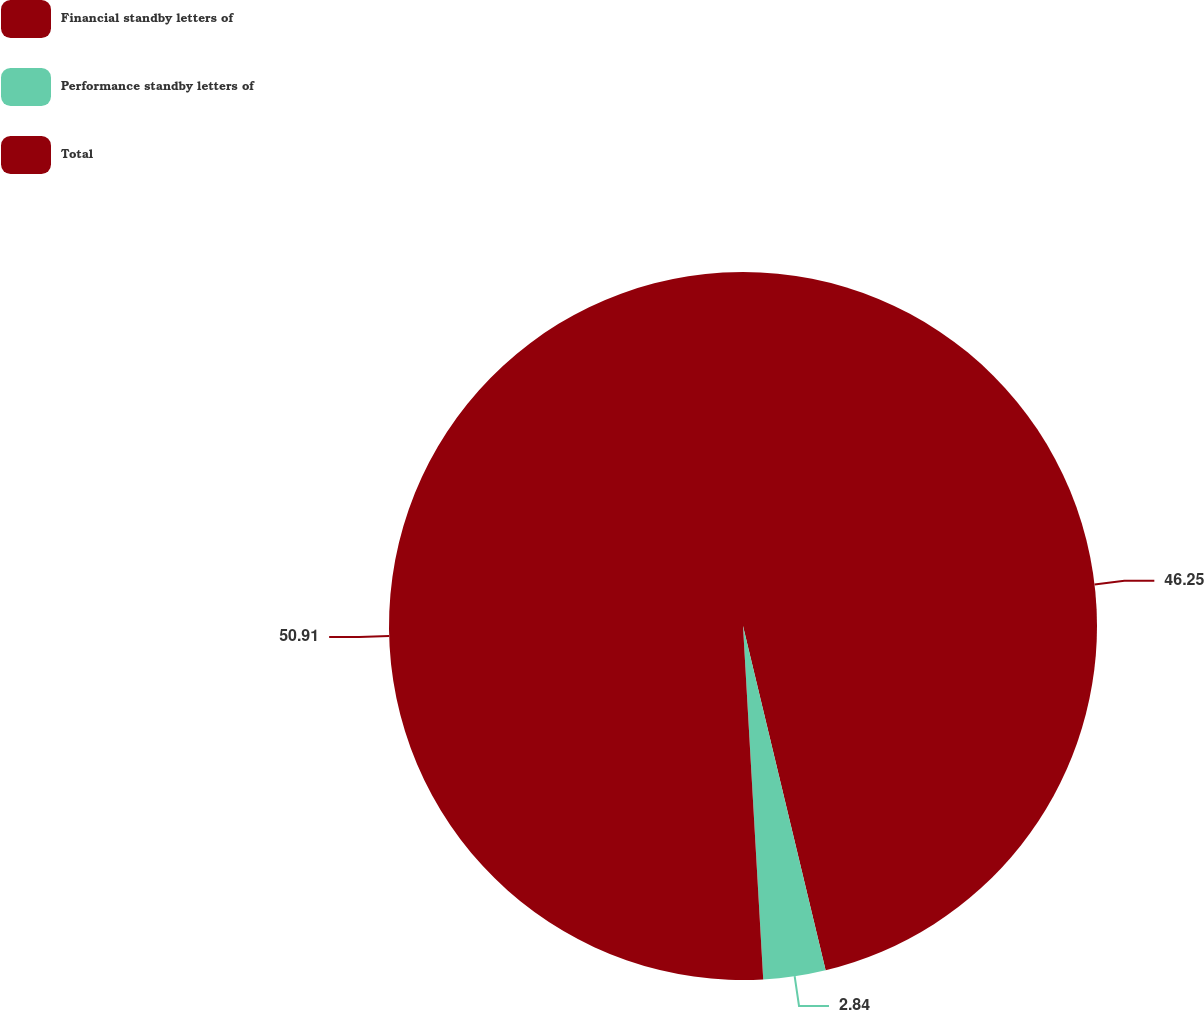Convert chart. <chart><loc_0><loc_0><loc_500><loc_500><pie_chart><fcel>Financial standby letters of<fcel>Performance standby letters of<fcel>Total<nl><fcel>46.25%<fcel>2.84%<fcel>50.91%<nl></chart> 